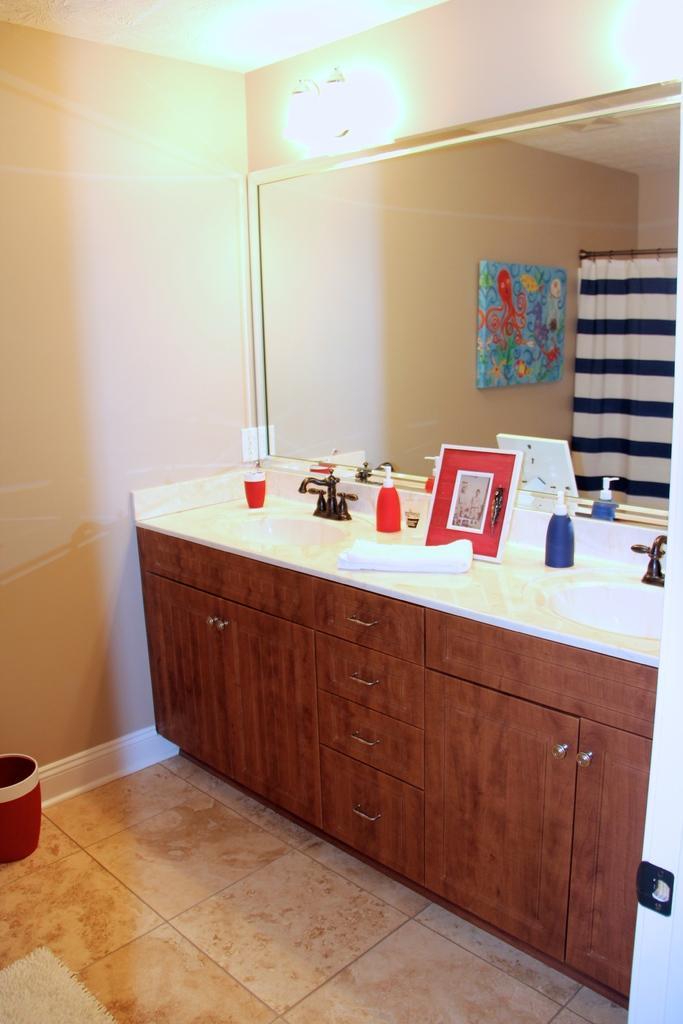How would you summarize this image in a sentence or two? In this picture there are cupboards and sanitary equipments on the right side of the image and there is a mirror on the right side of the image, there is lamp at the top side of the image. 